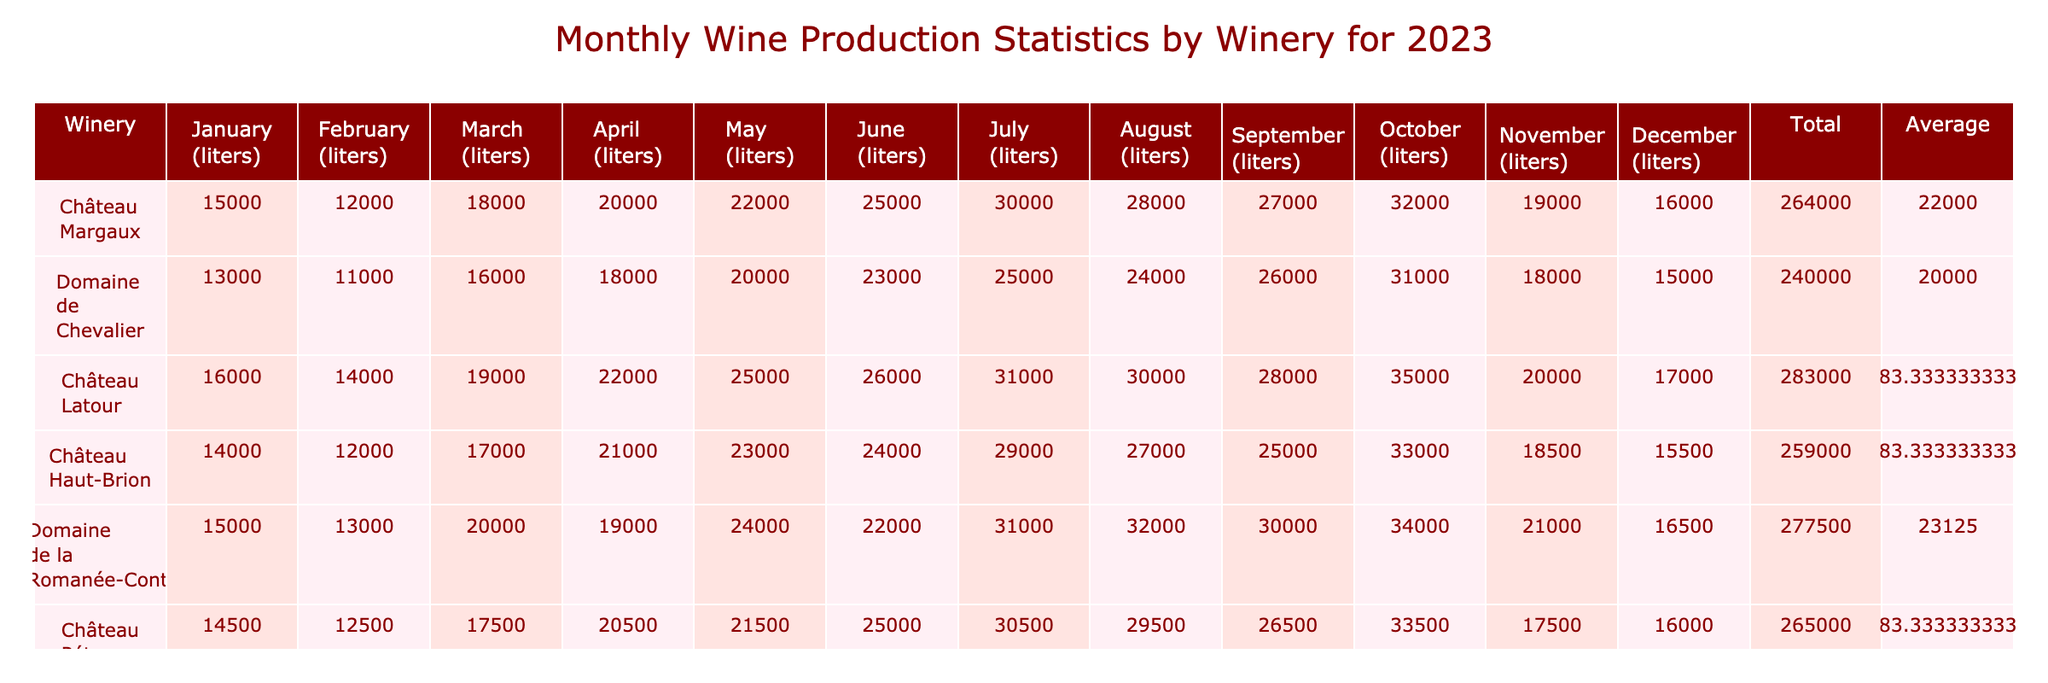What is the total wine production for Château Margaux in 2023? To find the total production for Château Margaux, we sum all the monthly production values: 15000 + 12000 + 18000 + 20000 + 22000 + 25000 + 30000 + 28000 + 27000 + 32000 + 19000 + 16000 = 275000 liters.
Answer: 275000 liters Which winery produced the most wine in July? In July, we compare the production values of each winery: Château Margaux (30000), Domaine de Chevalier (25000), Château Latour (31000), Château Haut-Brion (29000), Domaine de la Romanée-Conti (31000), and Château Pétrus (30500). Château Latour and Domaine de la Romanée-Conti both produced the most with 31000 liters.
Answer: Château Latour and Domaine de la Romanée-Conti What was the average production of Domaine de Chevalier across all months? To calculate the average production for Domaine de Chevalier, we sum the monthly values: 13000 + 11000 + 16000 + 18000 + 20000 + 23000 + 25000 + 24000 + 26000 + 31000 + 18000 + 15000 = 248000. We then divide this total by the number of months (12): 248000/12 = 20666.67 liters.
Answer: 20666.67 liters Did Château Pétrus produce more than 30000 liters in any month? Looking at the monthly production figures for Château Pétrus: January (14500), February (12500), March (17500), April (20500), May (21500), June (25000), July (30500), August (29500), September (26500), October (33500), November (17500), December (16000). Yes, in October, they produced 33500 liters, which is more than 30000 liters.
Answer: Yes In which month did Domaine de la Romanée-Conti have its highest production? We examine the monthly values for Domaine de la Romanée-Conti: January (15000), February (13000), March (20000), April (19000), May (24000), June (22000), July (31000), August (32000), September (30000), October (34000), November (21000), December (16500). October was the highest, with 34000 liters.
Answer: October 